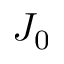<formula> <loc_0><loc_0><loc_500><loc_500>J _ { 0 }</formula> 